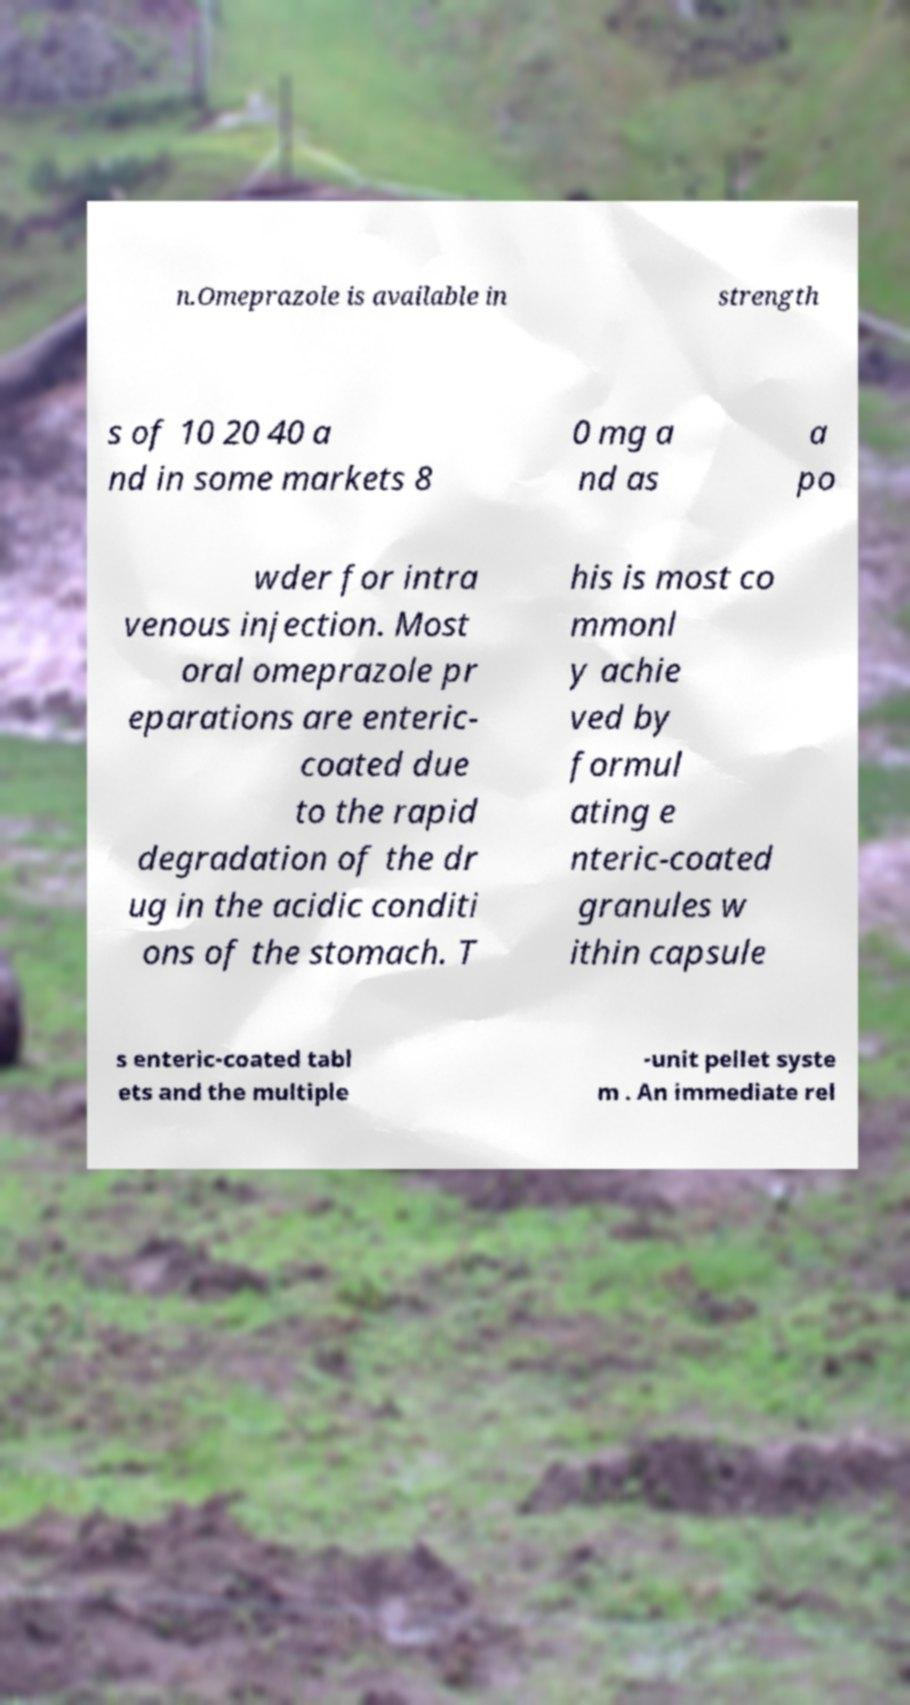Please identify and transcribe the text found in this image. n.Omeprazole is available in strength s of 10 20 40 a nd in some markets 8 0 mg a nd as a po wder for intra venous injection. Most oral omeprazole pr eparations are enteric- coated due to the rapid degradation of the dr ug in the acidic conditi ons of the stomach. T his is most co mmonl y achie ved by formul ating e nteric-coated granules w ithin capsule s enteric-coated tabl ets and the multiple -unit pellet syste m . An immediate rel 